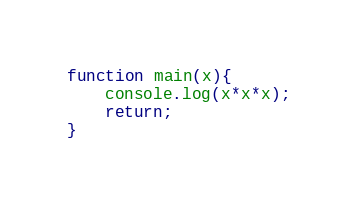Convert code to text. <code><loc_0><loc_0><loc_500><loc_500><_JavaScript_>function main(x){
    console.log(x*x*x);
    return;
}
</code> 